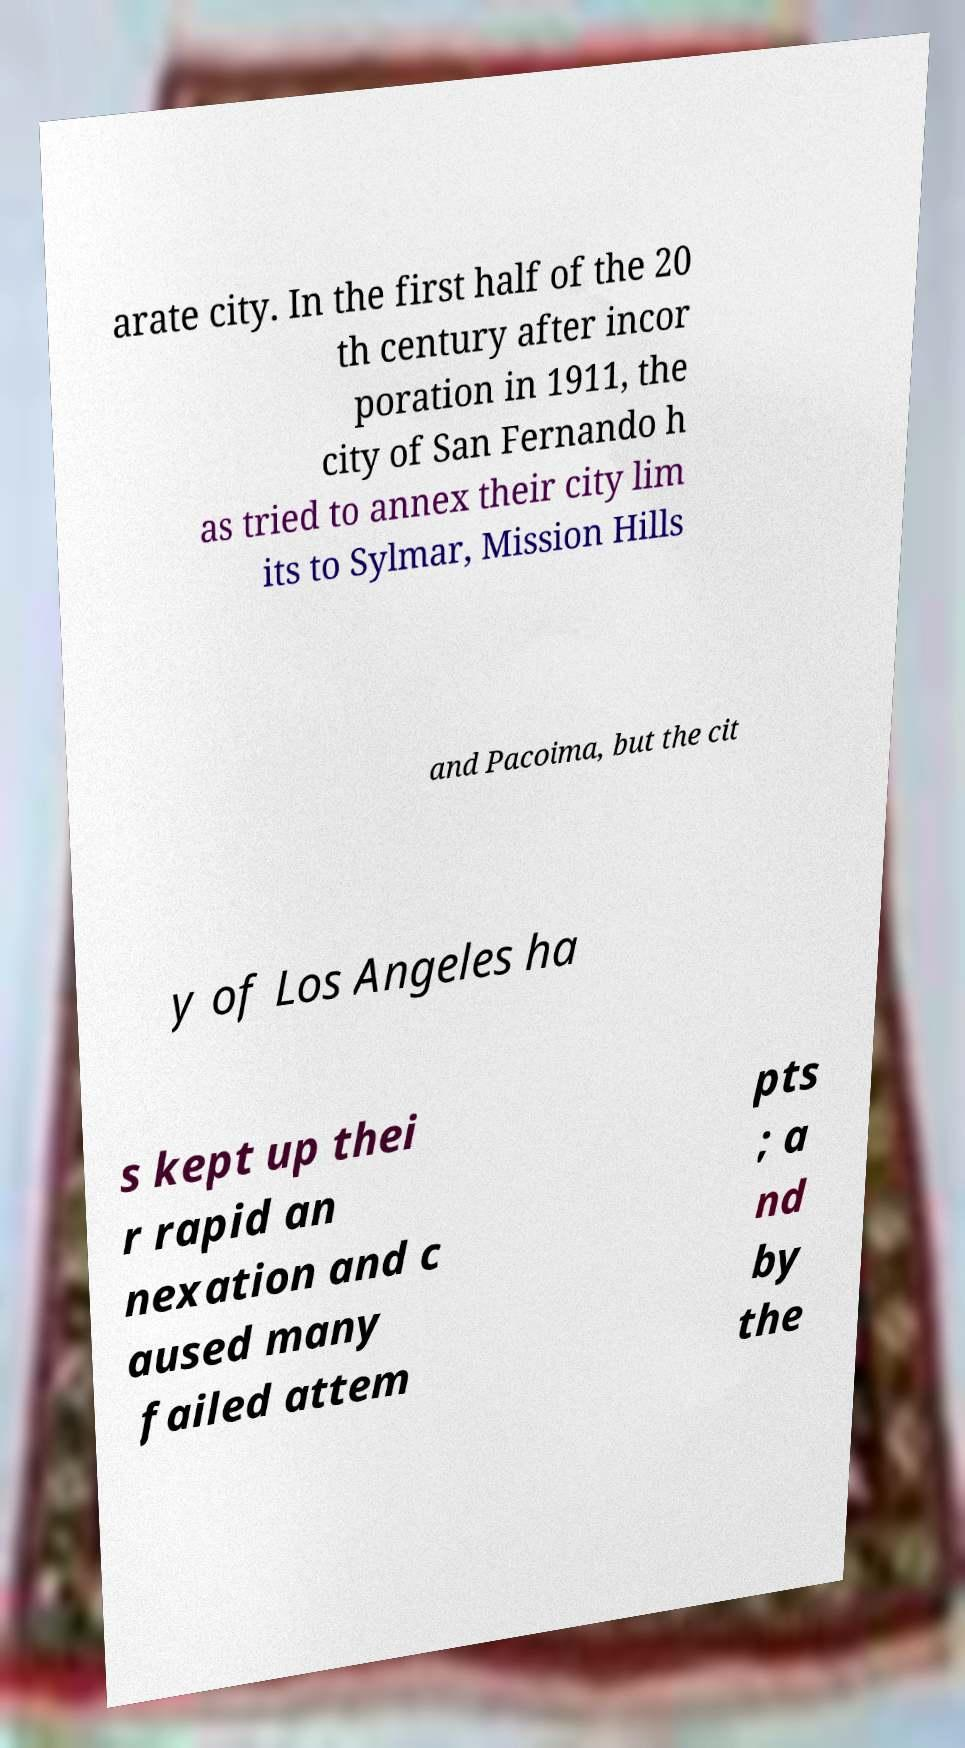Can you accurately transcribe the text from the provided image for me? arate city. In the first half of the 20 th century after incor poration in 1911, the city of San Fernando h as tried to annex their city lim its to Sylmar, Mission Hills and Pacoima, but the cit y of Los Angeles ha s kept up thei r rapid an nexation and c aused many failed attem pts ; a nd by the 